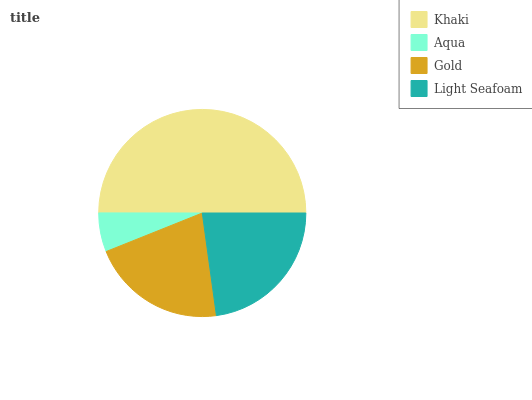Is Aqua the minimum?
Answer yes or no. Yes. Is Khaki the maximum?
Answer yes or no. Yes. Is Gold the minimum?
Answer yes or no. No. Is Gold the maximum?
Answer yes or no. No. Is Gold greater than Aqua?
Answer yes or no. Yes. Is Aqua less than Gold?
Answer yes or no. Yes. Is Aqua greater than Gold?
Answer yes or no. No. Is Gold less than Aqua?
Answer yes or no. No. Is Light Seafoam the high median?
Answer yes or no. Yes. Is Gold the low median?
Answer yes or no. Yes. Is Aqua the high median?
Answer yes or no. No. Is Light Seafoam the low median?
Answer yes or no. No. 